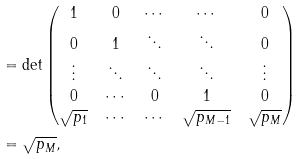<formula> <loc_0><loc_0><loc_500><loc_500>& = \det \begin{pmatrix} 1 & 0 & \cdots & \cdots & 0 \\ 0 & 1 & \ddots & \ddots & 0 \\ \vdots & \ddots & \ddots & \ddots & \vdots \\ 0 & \cdots & 0 & 1 & 0 \\ \sqrt { p _ { 1 } } & \cdots & \cdots & \sqrt { p _ { M - 1 } } & \sqrt { p _ { M } } \\ \end{pmatrix} \\ & = { \sqrt { p _ { M } } } ,</formula> 